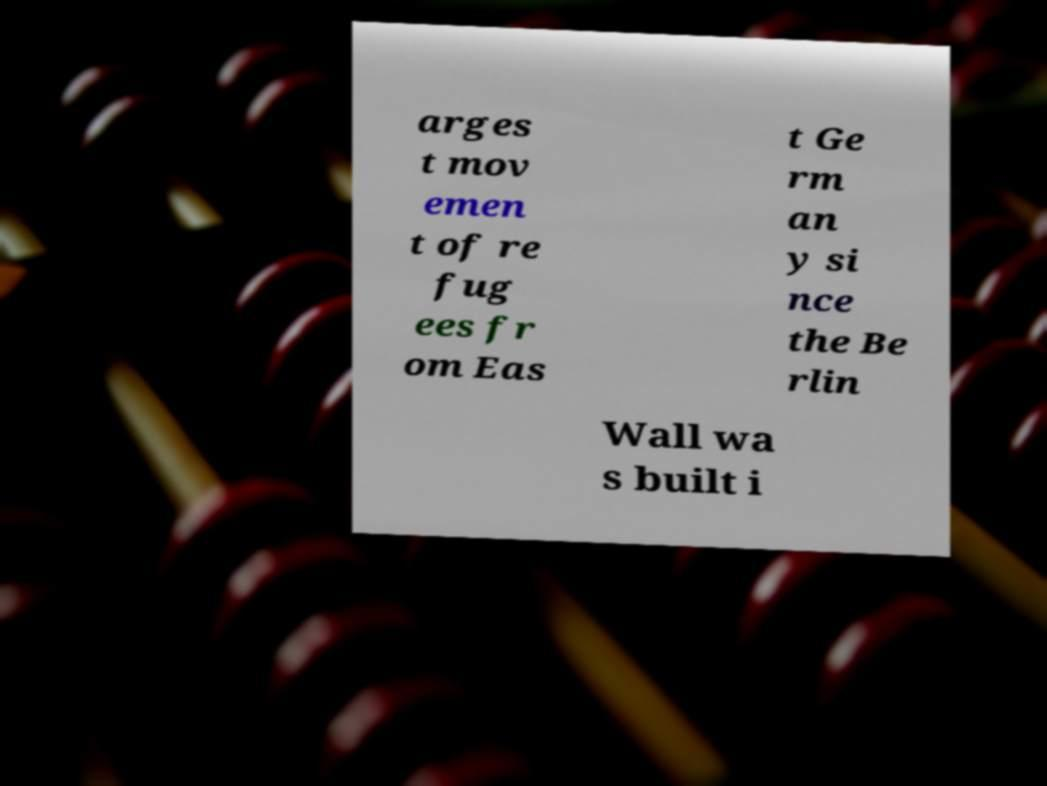Can you accurately transcribe the text from the provided image for me? arges t mov emen t of re fug ees fr om Eas t Ge rm an y si nce the Be rlin Wall wa s built i 